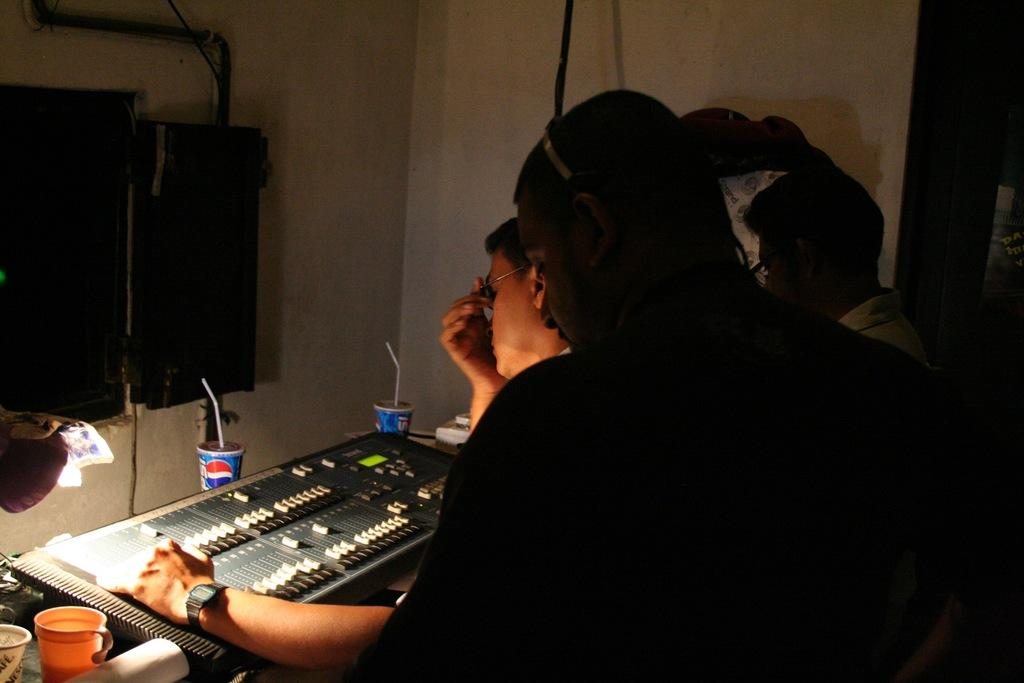Where is the setting of the image? The image is inside a room. How many people are present in the room? There are three people standing in the room. What can be found on the table in the image? There are cups, devices, and paper on the table. What is attached to the wall in the image? There is a device and a pipe on the wall. Are there any trees visible in the image? No, there are no trees visible in the image; the setting is inside a room. 